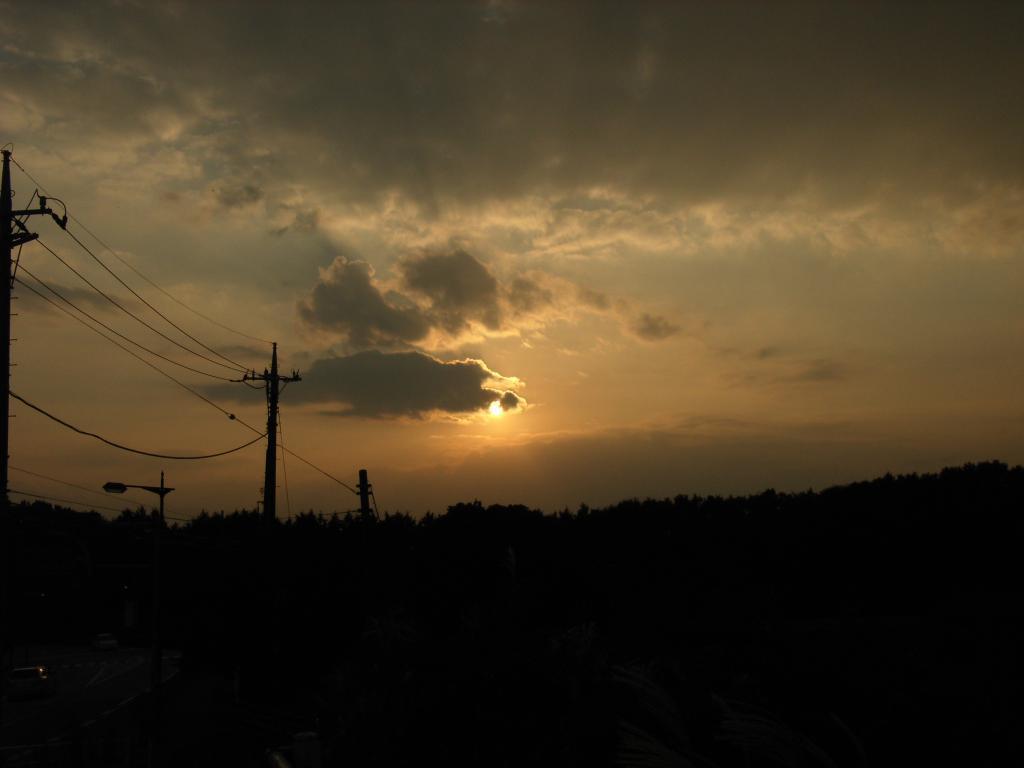In one or two sentences, can you explain what this image depicts? In the image there are electric poles on the left side with trees behind it and above its sky with clouds with sun in the middle. 